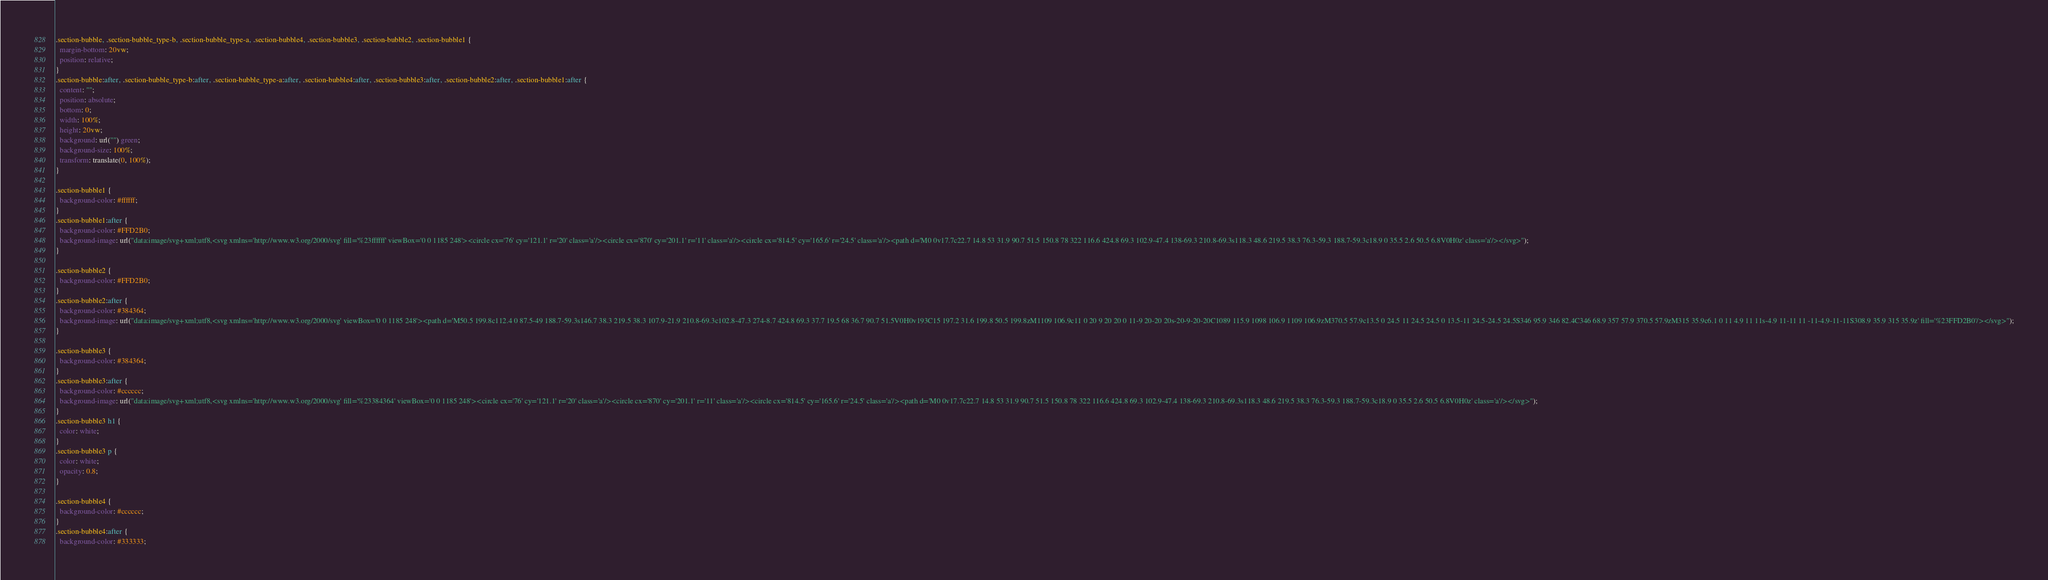<code> <loc_0><loc_0><loc_500><loc_500><_CSS_>.section-bubble, .section-bubble_type-b, .section-bubble_type-a, .section-bubble4, .section-bubble3, .section-bubble2, .section-bubble1 {
  margin-bottom: 20vw;
  position: relative;
}
.section-bubble:after, .section-bubble_type-b:after, .section-bubble_type-a:after, .section-bubble4:after, .section-bubble3:after, .section-bubble2:after, .section-bubble1:after {
  content: "";
  position: absolute;
  bottom: 0;
  width: 100%;
  height: 20vw;
  background: url("") green;
  background-size: 100%;
  transform: translate(0, 100%);
}

.section-bubble1 {
  background-color: #ffffff;
}
.section-bubble1:after {
  background-color: #FFD2B0;
  background-image: url("data:image/svg+xml;utf8,<svg xmlns='http://www.w3.org/2000/svg' fill='%23ffffff' viewBox='0 0 1185 248'><circle cx='76' cy='121.1' r='20' class='a'/><circle cx='870' cy='201.1' r='11' class='a'/><circle cx='814.5' cy='165.6' r='24.5' class='a'/><path d='M0 0v17.7c22.7 14.8 53 31.9 90.7 51.5 150.8 78 322 116.6 424.8 69.3 102.9-47.4 138-69.3 210.8-69.3s118.3 48.6 219.5 38.3 76.3-59.3 188.7-59.3c18.9 0 35.5 2.6 50.5 6.8V0H0z' class='a'/></svg>");
}

.section-bubble2 {
  background-color: #FFD2B0;
}
.section-bubble2:after {
  background-color: #384364;
  background-image: url("data:image/svg+xml;utf8,<svg xmlns='http://www.w3.org/2000/svg' viewBox='0 0 1185 248'><path d='M50.5 199.8c112.4 0 87.5-49 188.7-59.3s146.7 38.3 219.5 38.3 107.9-21.9 210.8-69.3c102.8-47.3 274-8.7 424.8 69.3 37.7 19.5 68 36.7 90.7 51.5V0H0v193C15 197.2 31.6 199.8 50.5 199.8zM1109 106.9c11 0 20 9 20 20 0 11-9 20-20 20s-20-9-20-20C1089 115.9 1098 106.9 1109 106.9zM370.5 57.9c13.5 0 24.5 11 24.5 24.5 0 13.5-11 24.5-24.5 24.5S346 95.9 346 82.4C346 68.9 357 57.9 370.5 57.9zM315 35.9c6.1 0 11 4.9 11 11s-4.9 11-11 11 -11-4.9-11-11S308.9 35.9 315 35.9z' fill='%23FFD2B0'/></svg>");
}

.section-bubble3 {
  background-color: #384364;
}
.section-bubble3:after {
  background-color: #cccccc;
  background-image: url("data:image/svg+xml;utf8,<svg xmlns='http://www.w3.org/2000/svg' fill='%23384364' viewBox='0 0 1185 248'><circle cx='76' cy='121.1' r='20' class='a'/><circle cx='870' cy='201.1' r='11' class='a'/><circle cx='814.5' cy='165.6' r='24.5' class='a'/><path d='M0 0v17.7c22.7 14.8 53 31.9 90.7 51.5 150.8 78 322 116.6 424.8 69.3 102.9-47.4 138-69.3 210.8-69.3s118.3 48.6 219.5 38.3 76.3-59.3 188.7-59.3c18.9 0 35.5 2.6 50.5 6.8V0H0z' class='a'/></svg>");
}
.section-bubble3 h1 {
  color: white;
}
.section-bubble3 p {
  color: white;
  opacity: 0.8;
}

.section-bubble4 {
  background-color: #cccccc;
}
.section-bubble4:after {
  background-color: #333333;</code> 